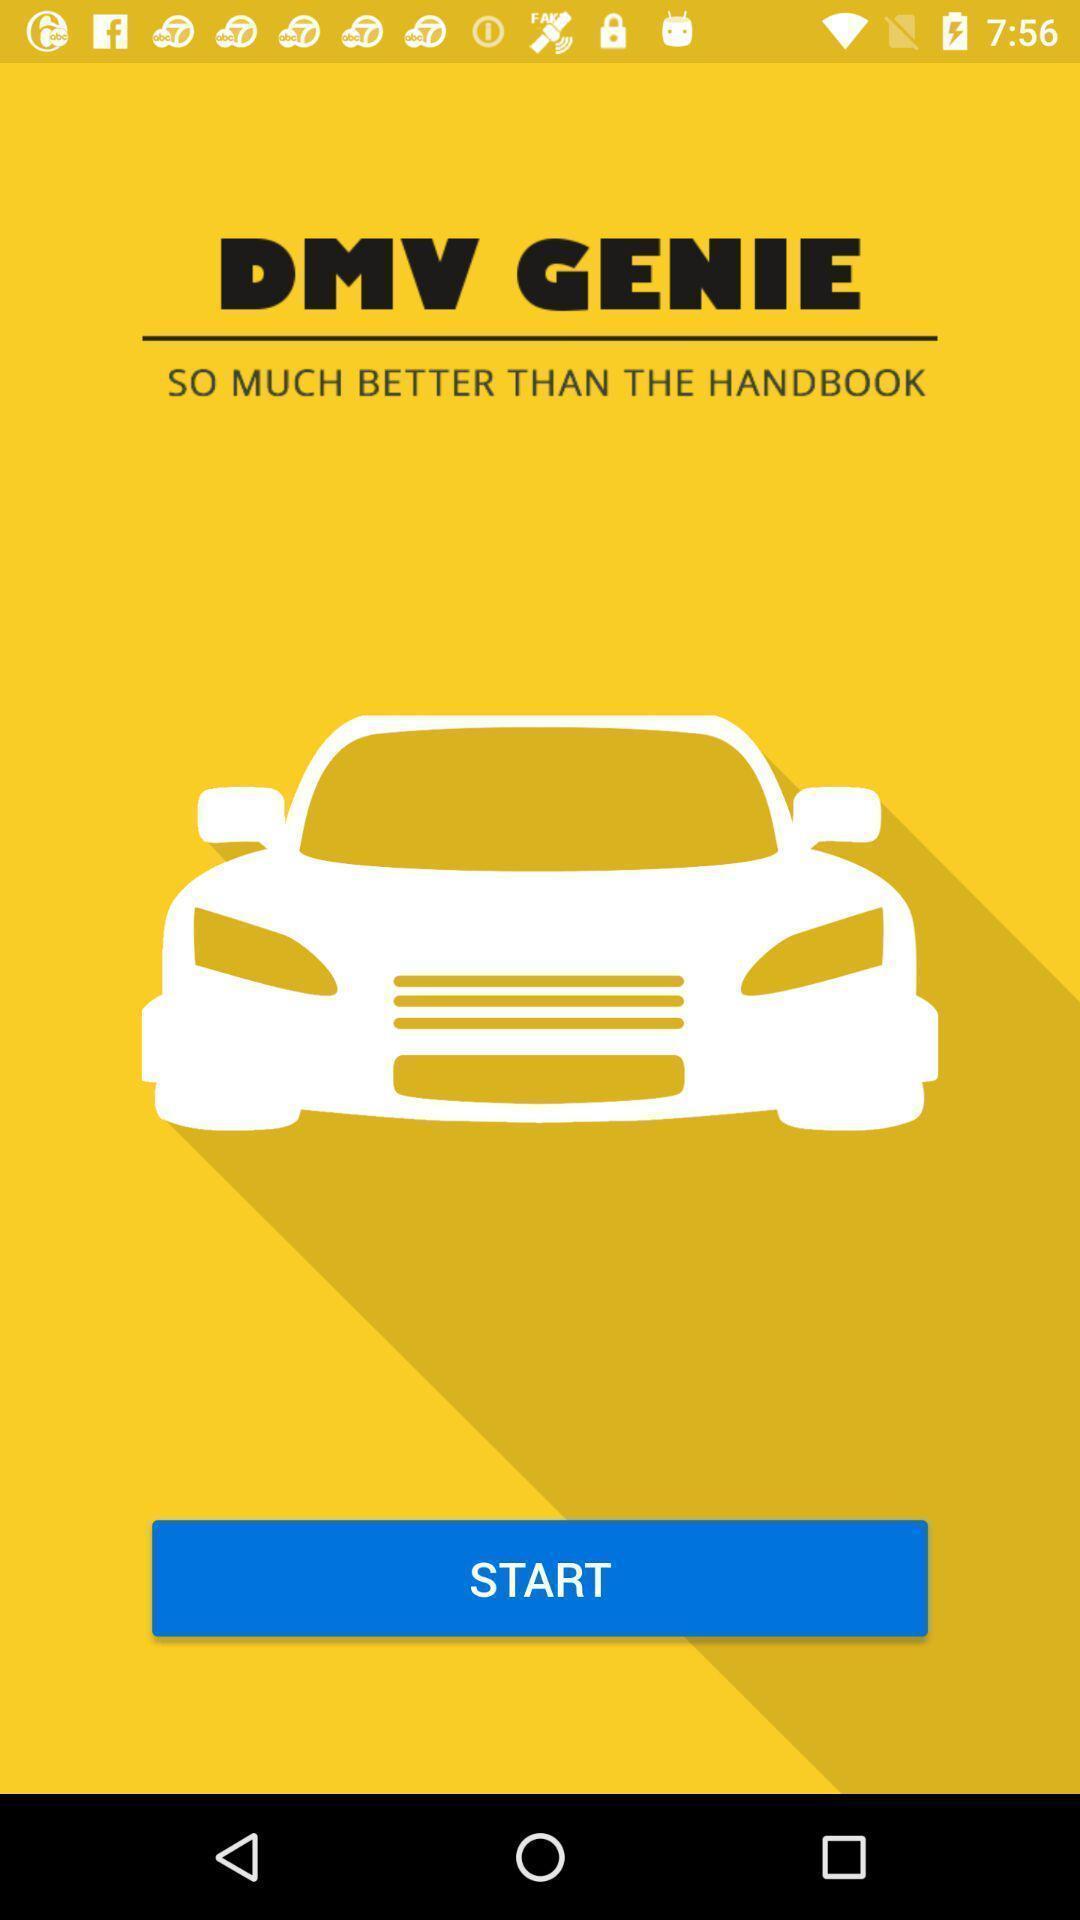Provide a textual representation of this image. Welcome page of a vehicle application. 